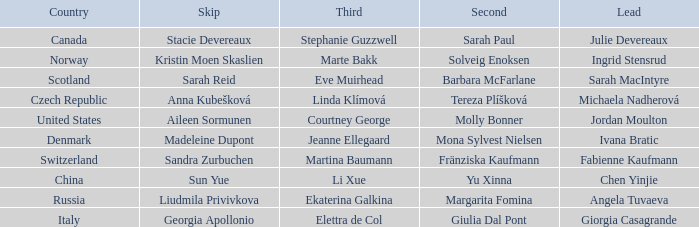What skip has norway as the country? Kristin Moen Skaslien. 